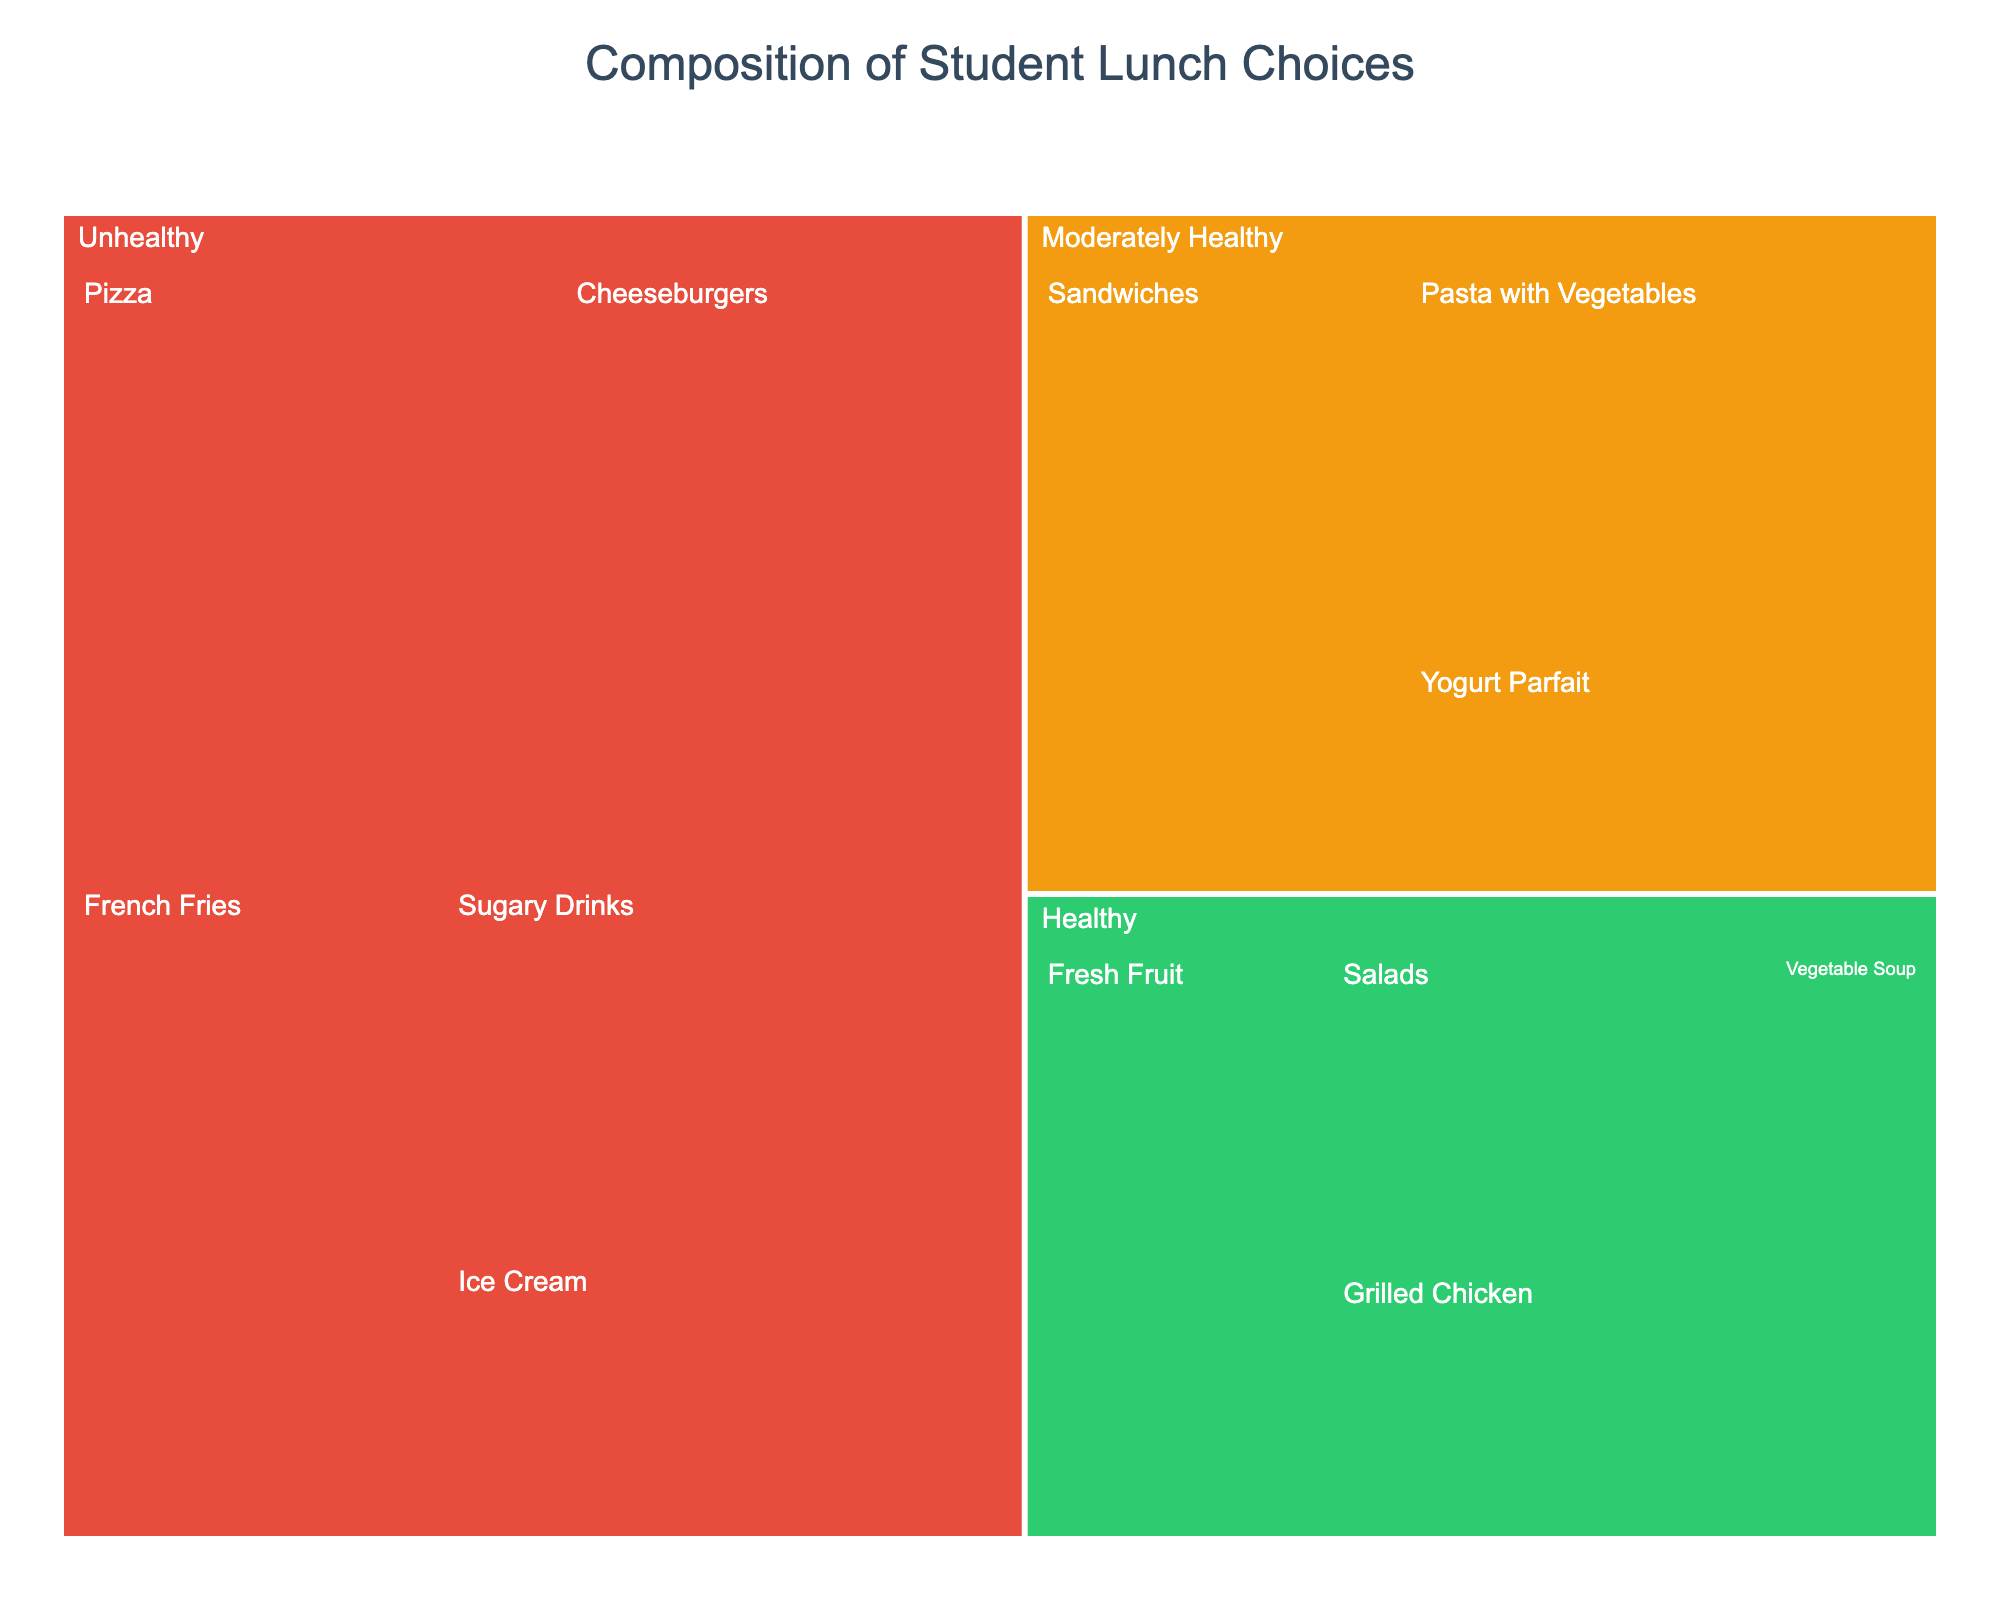What's the title of the treemap? The title is displayed at the top center of the treemap.
Answer: Composition of Student Lunch Choices Which category has the largest overall value? Sum the values of each subcategory within each category. Unhealthy: 50 + 45 + 40 + 35 + 25 = 195, Healthy: 25 + 20 + 30 + 15 = 90, Moderately Healthy: 40 + 35 + 20 = 95. Unhealthy has the largest value.
Answer: Unhealthy What is the total value for the Healthy category? Add the values for all Healthy subcategories: Salads (25) + Grilled Chicken (20) + Fresh Fruit (30) + Vegetable Soup (15). The sum is 25 + 20 + 30 + 15 = 90.
Answer: 90 Which subcategory in the Unhealthy category has the smallest value? Compare the values of each subcategory: Pizza (50), Cheeseburgers (45), French Fries (40), Sugary Drinks (35), Ice Cream (25). The smallest value is Ice Cream with 25.
Answer: Ice Cream What is the difference in value between Sandwiches and Pizza? First, find the values: Sandwiches (40), Pizza (50). Then subtract the value of Sandwiches from Pizza: 50 - 40 = 10.
Answer: 10 What is the combined value of Salads and Fresh Fruit? Add the values of the two subcategories: Salads (25) + Fresh Fruit (30). The sum is 25 + 30 = 55.
Answer: 55 How many subcategories are displayed in the treemap? Count the number of subcategories listed under each category. Healthy has 4, Moderately Healthy has 3, and Unhealthy has 5. The total is 4 + 3 + 5 = 12.
Answer: 12 Which category is displayed in green? Identify the color coding: Green represents Healthy, Orange represents Moderately Healthy, and Red represents Unhealthy. Green is for Healthy.
Answer: Healthy Which category has the highest single subcategory value? Compare the highest values within each category: Healthy (Fresh Fruit, 30), Moderately Healthy (Sandwiches, 40), Unhealthy (Pizza, 50). The highest is in Unhealthy with 50 (Pizza).
Answer: Unhealthy Is the value of Yogurt Parfait higher or lower than Ice Cream? Compare the values: Yogurt Parfait (20) and Ice Cream (25). Yogurt Parfait's value is lower.
Answer: Lower 